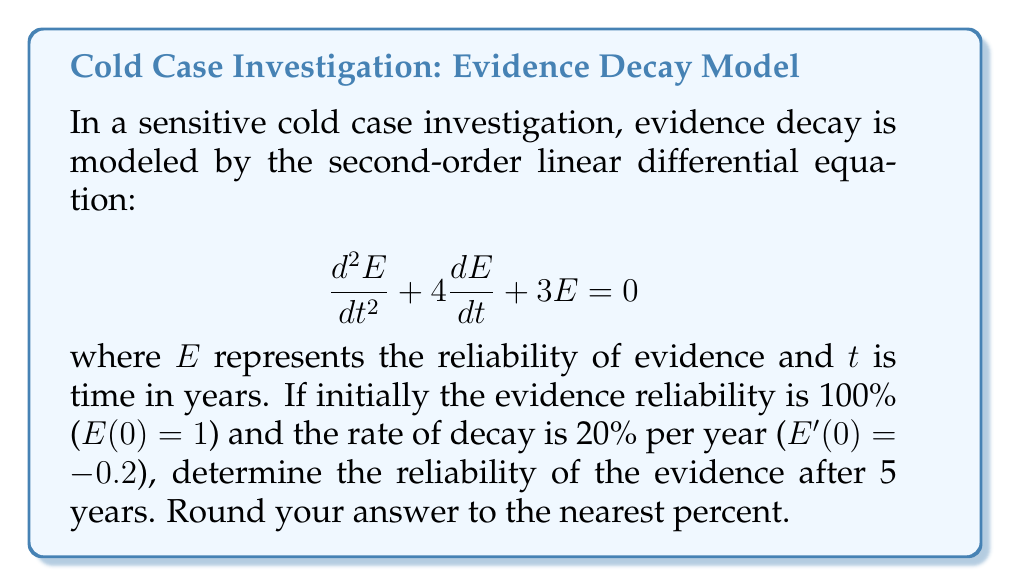Teach me how to tackle this problem. 1) The characteristic equation for this differential equation is:
   $r^2 + 4r + 3 = 0$

2) Solving this quadratic equation:
   $(r + 1)(r + 3) = 0$
   $r = -1$ or $r = -3$

3) The general solution is:
   $E(t) = c_1e^{-t} + c_2e^{-3t}$

4) To find $c_1$ and $c_2$, we use the initial conditions:
   $E(0) = 1$: $c_1 + c_2 = 1$
   $E'(0) = -0.2$: $-c_1 - 3c_2 = -0.2$

5) Solving these equations:
   $c_1 = 0.7$ and $c_2 = 0.3$

6) Therefore, the particular solution is:
   $E(t) = 0.7e^{-t} + 0.3e^{-3t}$

7) To find the reliability after 5 years, we calculate $E(5)$:
   $E(5) = 0.7e^{-5} + 0.3e^{-15}$

8) Using a calculator:
   $E(5) \approx 0.0461 + 0.0000 \approx 0.0461$

9) Converting to a percentage and rounding to the nearest percent:
   $0.0461 * 100\% \approx 5\%$
Answer: 5% 